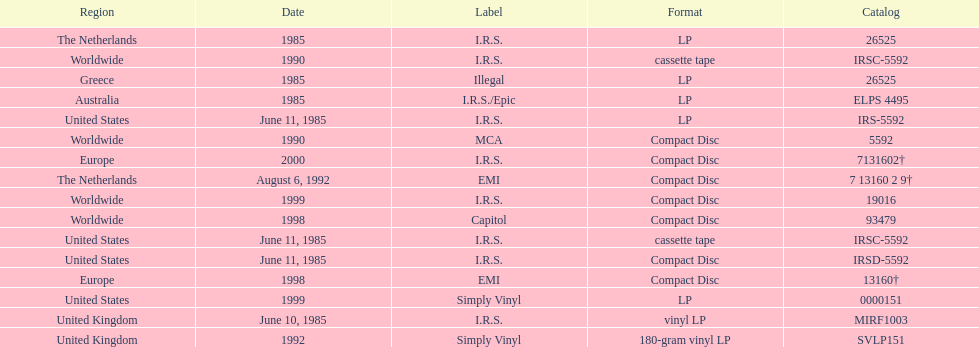Which region has more than one format? United States. 